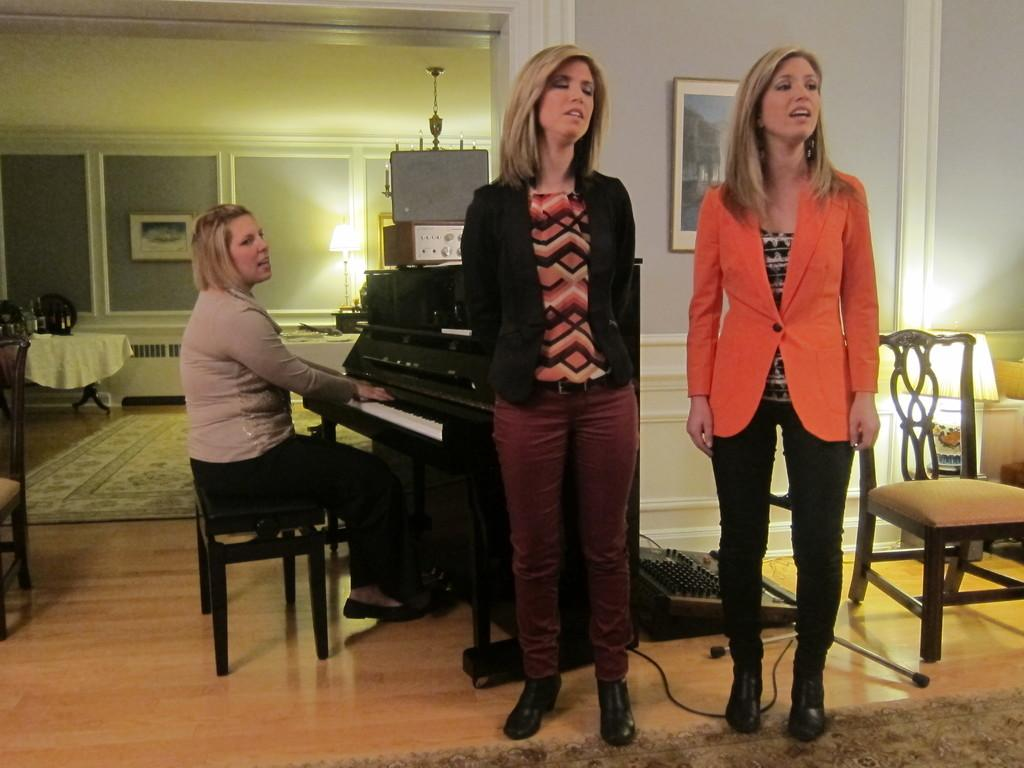How many people are present in the image? There are two people standing in the image. What is one of the people doing in the image? There is a lady playing the piano in the image. What type of plants can be seen growing on the coat of the lady playing the piano? There are no plants visible on the coat of the lady playing the piano in the image. How many trains are passing by in the background of the image? There are no trains present in the image. 